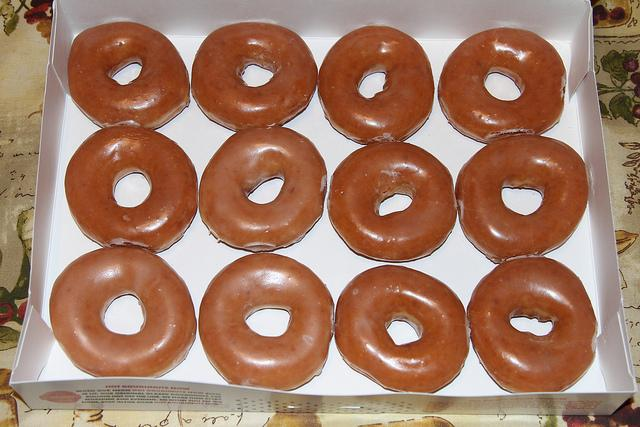What type of coating is found on the paper below the donuts?

Choices:
A) food coloring
B) glue
C) wax
D) ash wax 